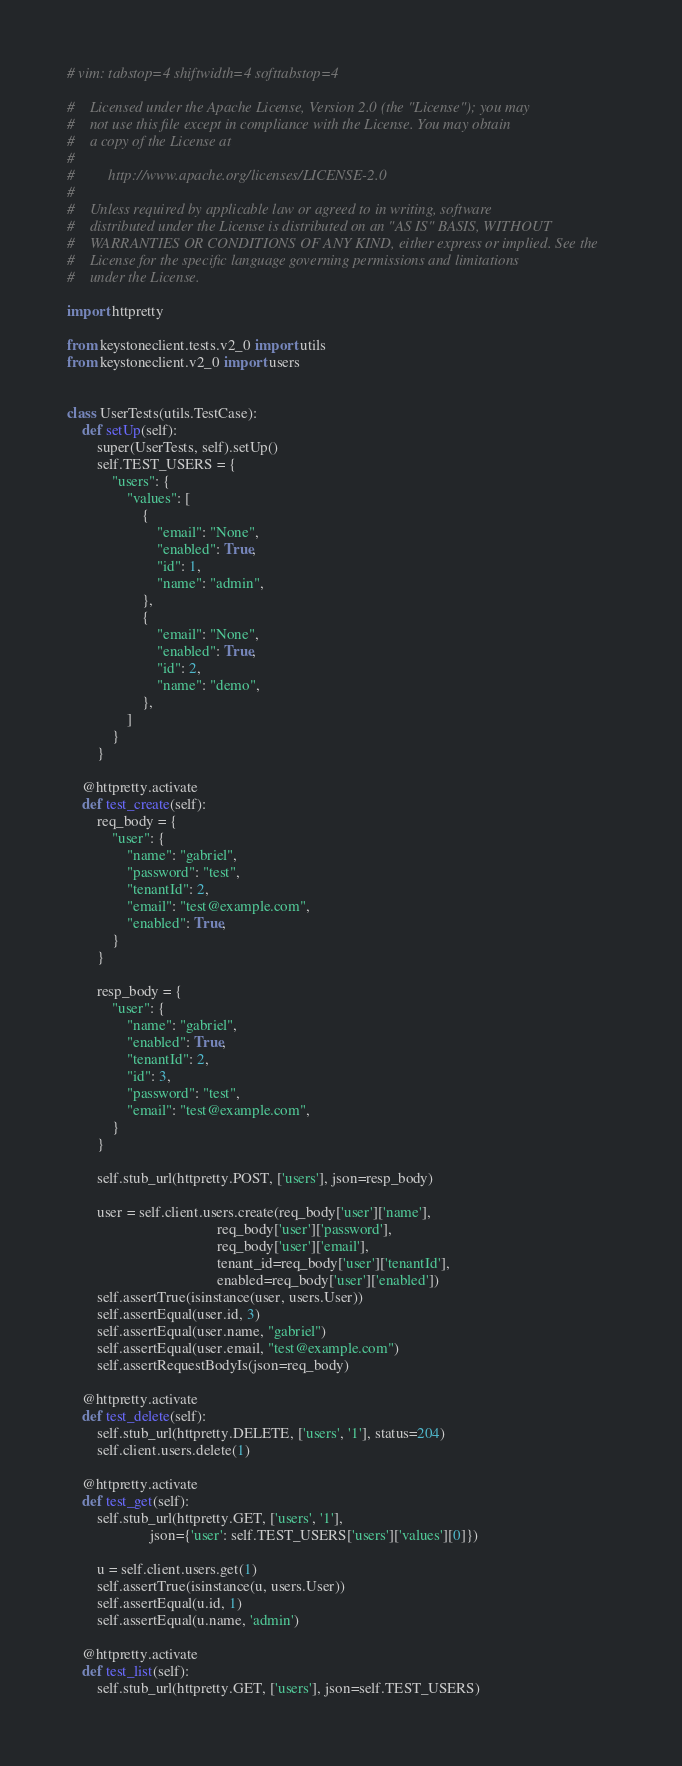Convert code to text. <code><loc_0><loc_0><loc_500><loc_500><_Python_># vim: tabstop=4 shiftwidth=4 softtabstop=4

#    Licensed under the Apache License, Version 2.0 (the "License"); you may
#    not use this file except in compliance with the License. You may obtain
#    a copy of the License at
#
#         http://www.apache.org/licenses/LICENSE-2.0
#
#    Unless required by applicable law or agreed to in writing, software
#    distributed under the License is distributed on an "AS IS" BASIS, WITHOUT
#    WARRANTIES OR CONDITIONS OF ANY KIND, either express or implied. See the
#    License for the specific language governing permissions and limitations
#    under the License.

import httpretty

from keystoneclient.tests.v2_0 import utils
from keystoneclient.v2_0 import users


class UserTests(utils.TestCase):
    def setUp(self):
        super(UserTests, self).setUp()
        self.TEST_USERS = {
            "users": {
                "values": [
                    {
                        "email": "None",
                        "enabled": True,
                        "id": 1,
                        "name": "admin",
                    },
                    {
                        "email": "None",
                        "enabled": True,
                        "id": 2,
                        "name": "demo",
                    },
                ]
            }
        }

    @httpretty.activate
    def test_create(self):
        req_body = {
            "user": {
                "name": "gabriel",
                "password": "test",
                "tenantId": 2,
                "email": "test@example.com",
                "enabled": True,
            }
        }

        resp_body = {
            "user": {
                "name": "gabriel",
                "enabled": True,
                "tenantId": 2,
                "id": 3,
                "password": "test",
                "email": "test@example.com",
            }
        }

        self.stub_url(httpretty.POST, ['users'], json=resp_body)

        user = self.client.users.create(req_body['user']['name'],
                                        req_body['user']['password'],
                                        req_body['user']['email'],
                                        tenant_id=req_body['user']['tenantId'],
                                        enabled=req_body['user']['enabled'])
        self.assertTrue(isinstance(user, users.User))
        self.assertEqual(user.id, 3)
        self.assertEqual(user.name, "gabriel")
        self.assertEqual(user.email, "test@example.com")
        self.assertRequestBodyIs(json=req_body)

    @httpretty.activate
    def test_delete(self):
        self.stub_url(httpretty.DELETE, ['users', '1'], status=204)
        self.client.users.delete(1)

    @httpretty.activate
    def test_get(self):
        self.stub_url(httpretty.GET, ['users', '1'],
                      json={'user': self.TEST_USERS['users']['values'][0]})

        u = self.client.users.get(1)
        self.assertTrue(isinstance(u, users.User))
        self.assertEqual(u.id, 1)
        self.assertEqual(u.name, 'admin')

    @httpretty.activate
    def test_list(self):
        self.stub_url(httpretty.GET, ['users'], json=self.TEST_USERS)
</code> 